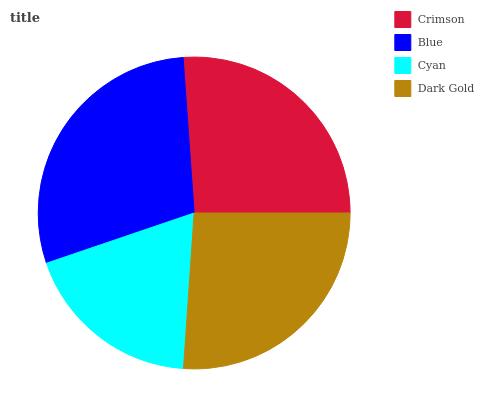Is Cyan the minimum?
Answer yes or no. Yes. Is Blue the maximum?
Answer yes or no. Yes. Is Blue the minimum?
Answer yes or no. No. Is Cyan the maximum?
Answer yes or no. No. Is Blue greater than Cyan?
Answer yes or no. Yes. Is Cyan less than Blue?
Answer yes or no. Yes. Is Cyan greater than Blue?
Answer yes or no. No. Is Blue less than Cyan?
Answer yes or no. No. Is Crimson the high median?
Answer yes or no. Yes. Is Dark Gold the low median?
Answer yes or no. Yes. Is Cyan the high median?
Answer yes or no. No. Is Blue the low median?
Answer yes or no. No. 